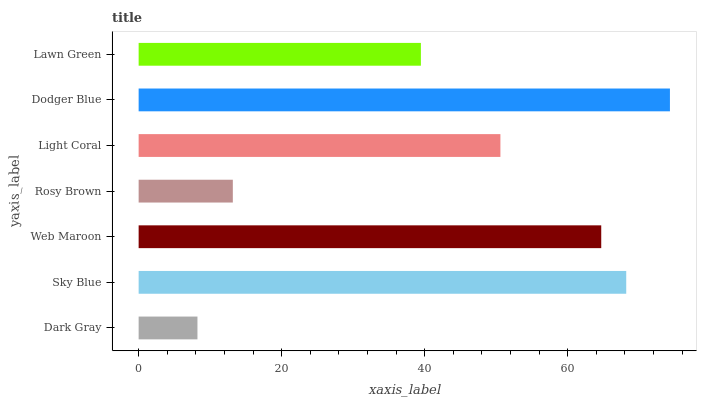Is Dark Gray the minimum?
Answer yes or no. Yes. Is Dodger Blue the maximum?
Answer yes or no. Yes. Is Sky Blue the minimum?
Answer yes or no. No. Is Sky Blue the maximum?
Answer yes or no. No. Is Sky Blue greater than Dark Gray?
Answer yes or no. Yes. Is Dark Gray less than Sky Blue?
Answer yes or no. Yes. Is Dark Gray greater than Sky Blue?
Answer yes or no. No. Is Sky Blue less than Dark Gray?
Answer yes or no. No. Is Light Coral the high median?
Answer yes or no. Yes. Is Light Coral the low median?
Answer yes or no. Yes. Is Dark Gray the high median?
Answer yes or no. No. Is Dodger Blue the low median?
Answer yes or no. No. 